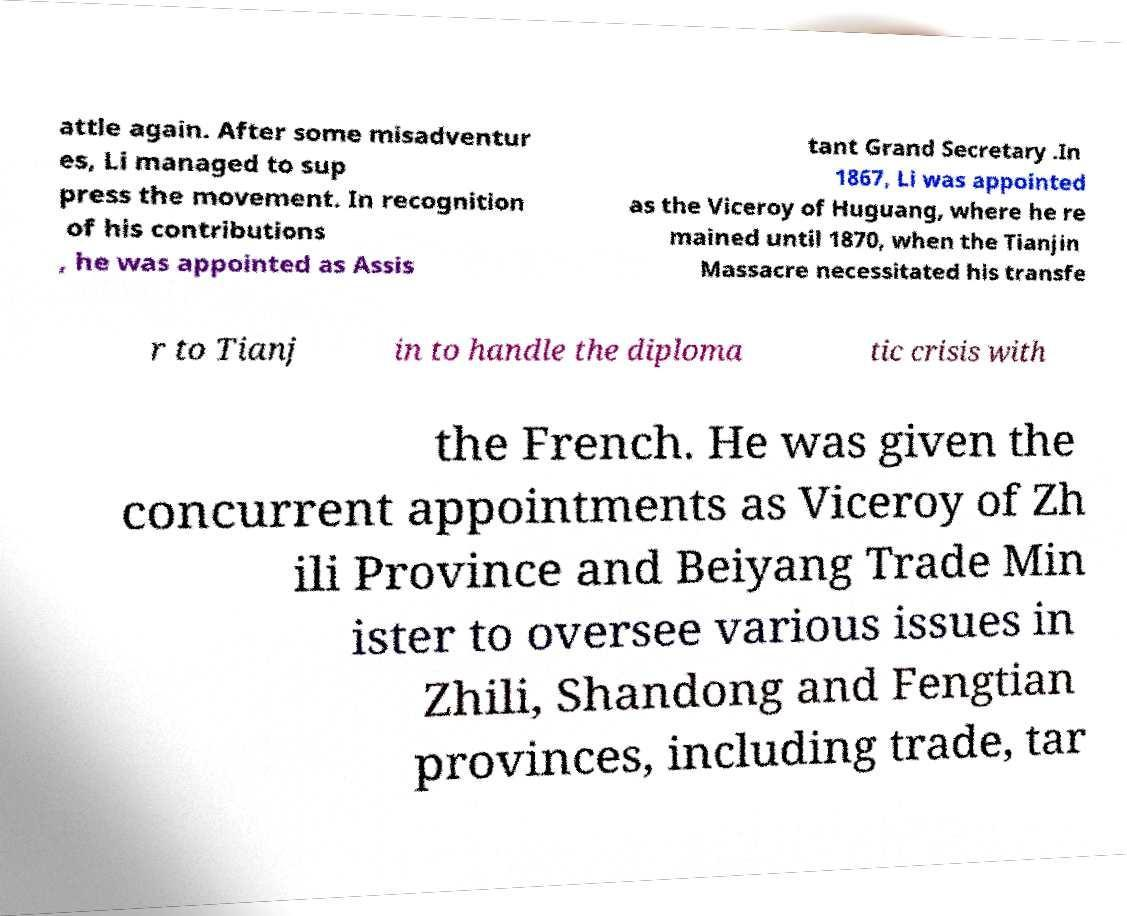I need the written content from this picture converted into text. Can you do that? attle again. After some misadventur es, Li managed to sup press the movement. In recognition of his contributions , he was appointed as Assis tant Grand Secretary .In 1867, Li was appointed as the Viceroy of Huguang, where he re mained until 1870, when the Tianjin Massacre necessitated his transfe r to Tianj in to handle the diploma tic crisis with the French. He was given the concurrent appointments as Viceroy of Zh ili Province and Beiyang Trade Min ister to oversee various issues in Zhili, Shandong and Fengtian provinces, including trade, tar 